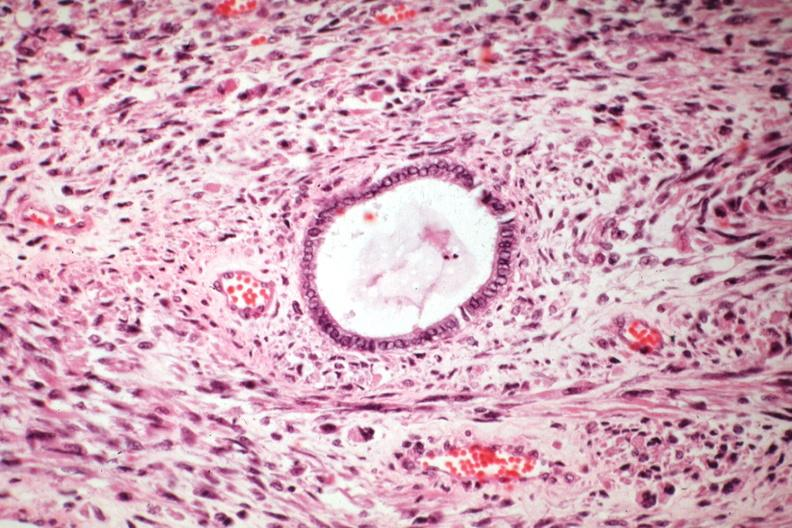what is present?
Answer the question using a single word or phrase. Female reproductive 